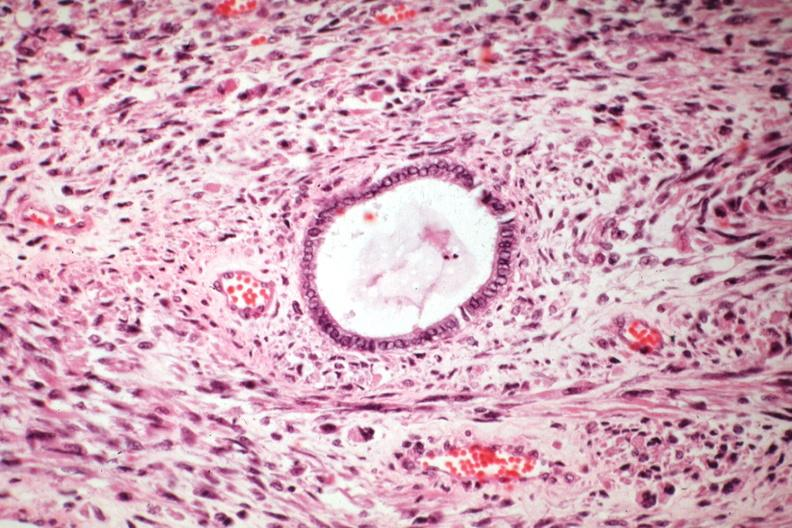what is present?
Answer the question using a single word or phrase. Female reproductive 